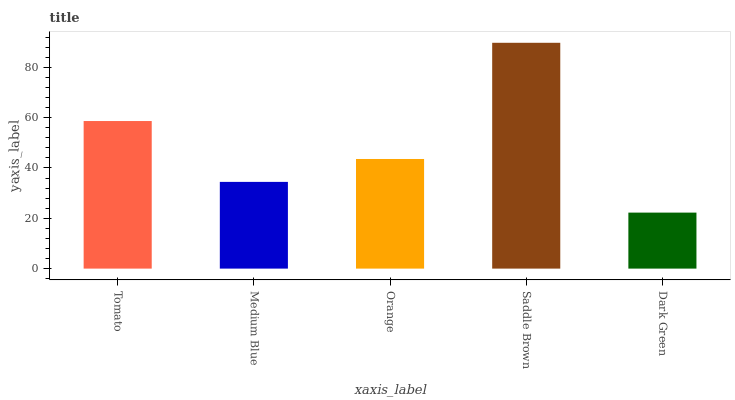Is Dark Green the minimum?
Answer yes or no. Yes. Is Saddle Brown the maximum?
Answer yes or no. Yes. Is Medium Blue the minimum?
Answer yes or no. No. Is Medium Blue the maximum?
Answer yes or no. No. Is Tomato greater than Medium Blue?
Answer yes or no. Yes. Is Medium Blue less than Tomato?
Answer yes or no. Yes. Is Medium Blue greater than Tomato?
Answer yes or no. No. Is Tomato less than Medium Blue?
Answer yes or no. No. Is Orange the high median?
Answer yes or no. Yes. Is Orange the low median?
Answer yes or no. Yes. Is Saddle Brown the high median?
Answer yes or no. No. Is Dark Green the low median?
Answer yes or no. No. 